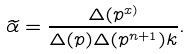Convert formula to latex. <formula><loc_0><loc_0><loc_500><loc_500>\widetilde { \alpha } = \frac { \Delta ( p ^ { x ) } } { \Delta ( p ) \Delta ( p ^ { n + 1 } ) k } .</formula> 